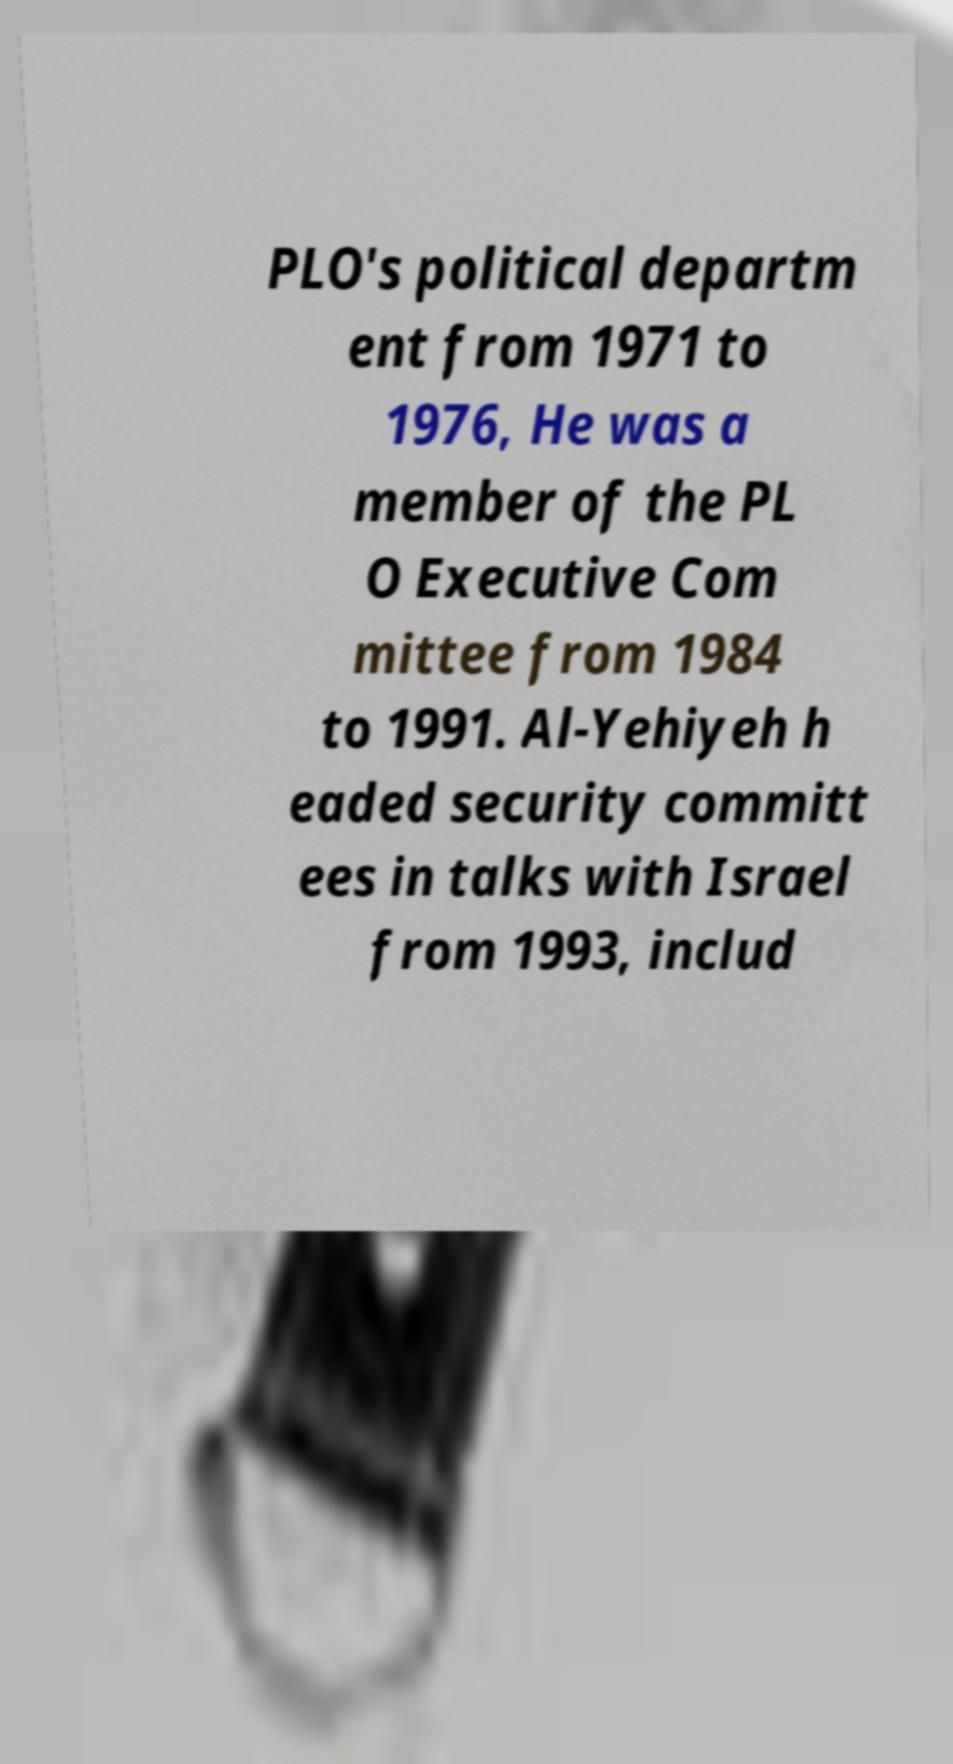Please identify and transcribe the text found in this image. PLO's political departm ent from 1971 to 1976, He was a member of the PL O Executive Com mittee from 1984 to 1991. Al-Yehiyeh h eaded security committ ees in talks with Israel from 1993, includ 